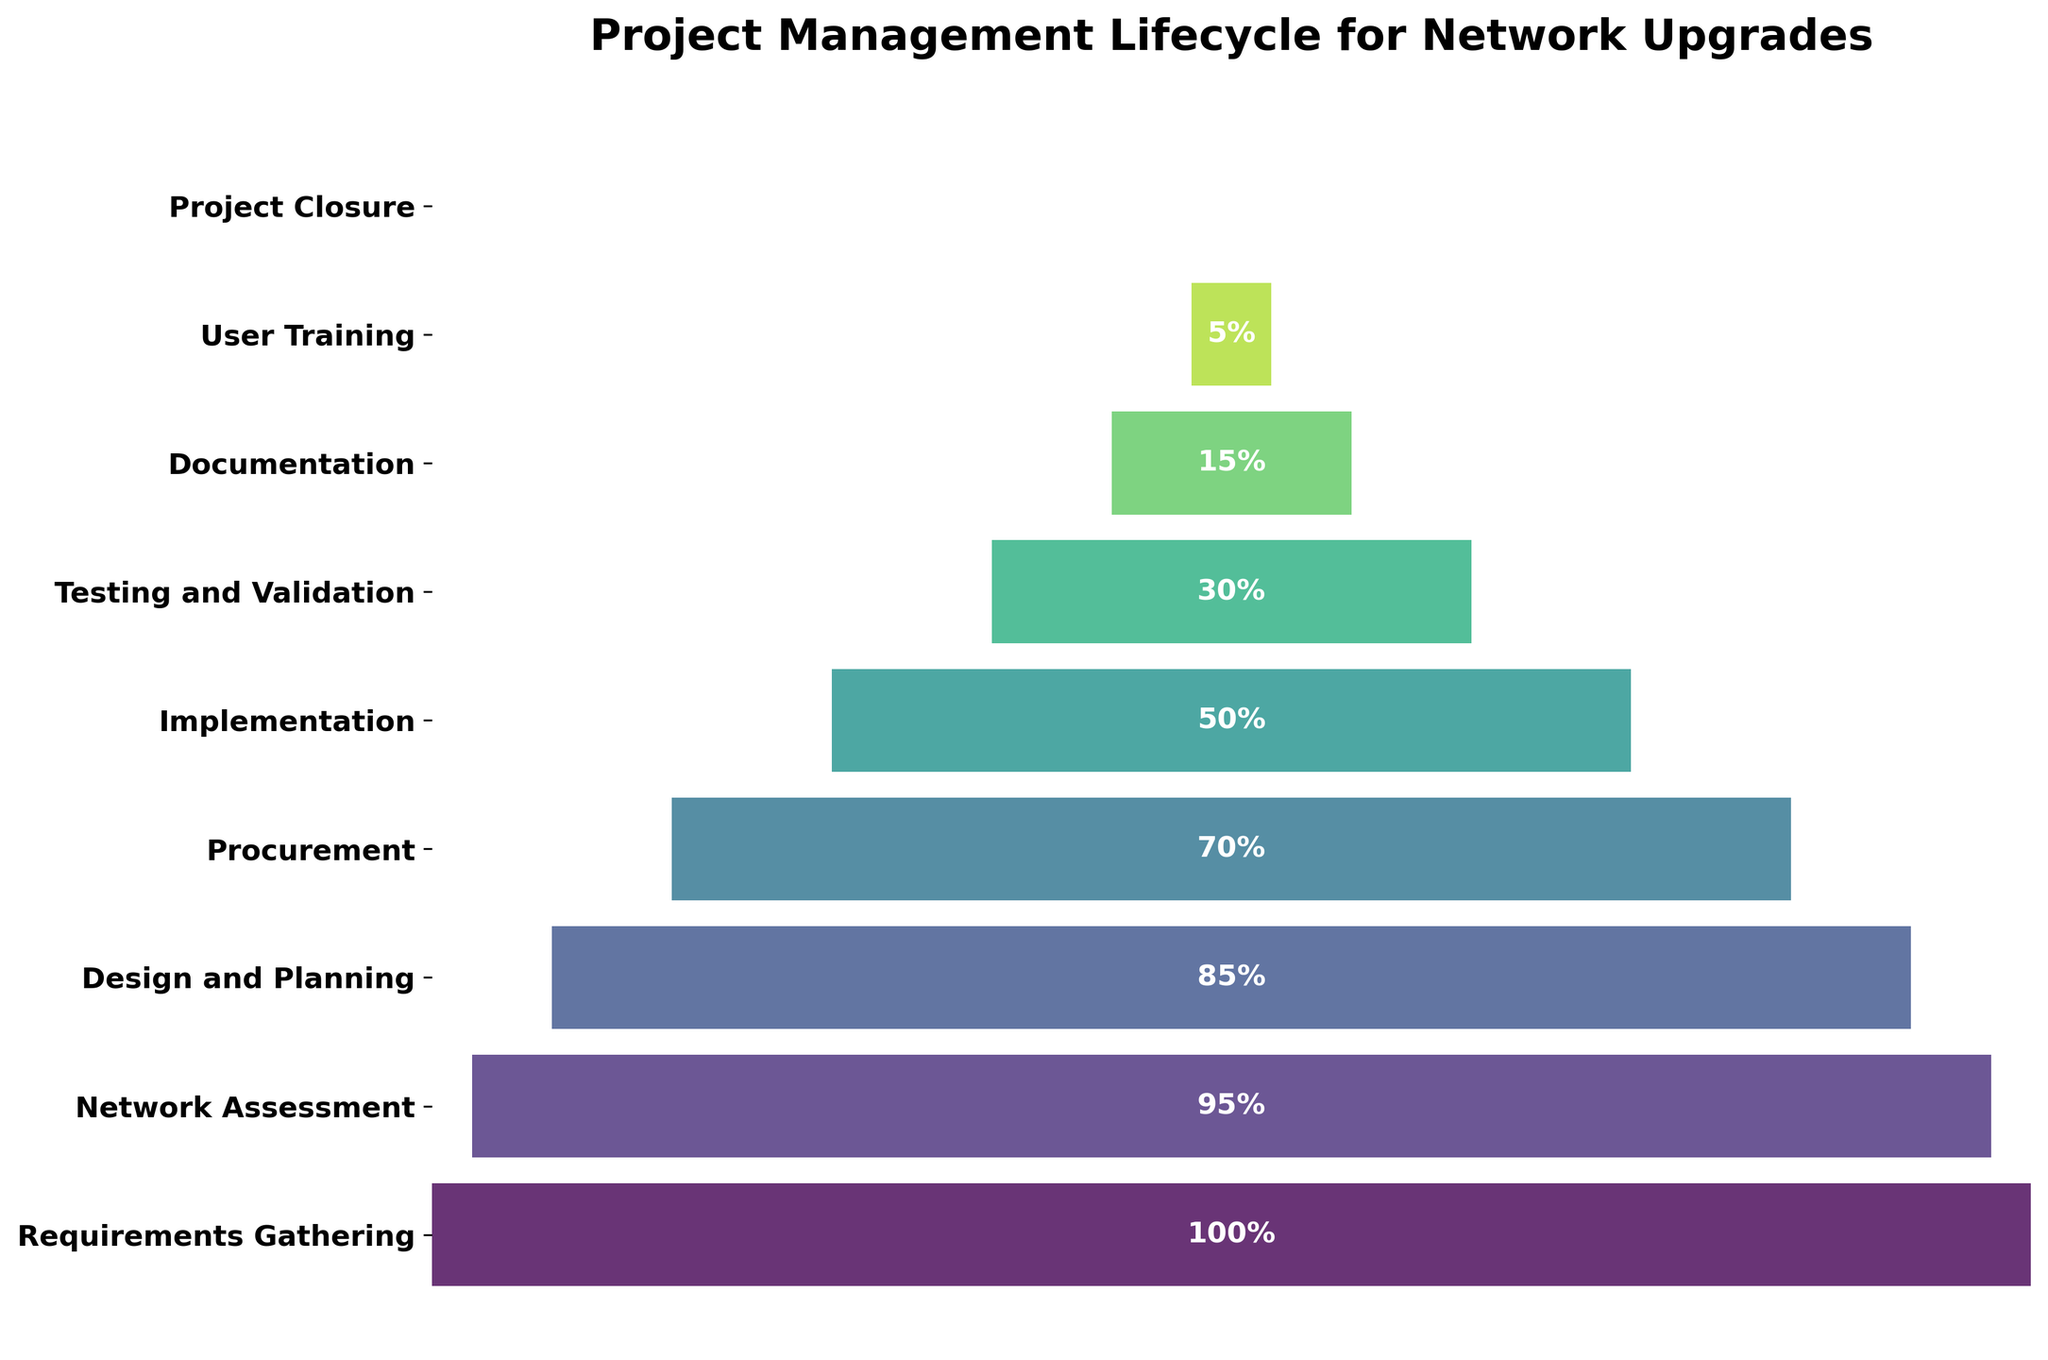Which phase has the highest completion percentage? The phase with the highest completion percentage is the one shown at the top of the funnel chart. By inspecting the chart, we can see that the topmost phase, "Requirements Gathering," has a completion percentage of 100%.
Answer: Requirements Gathering What is the difference in completion percentage between the "Procurement" and "Testing and Validation" phases? The completion percentage for "Procurement" is 70%, and for "Testing and Validation" it is 30%. The difference can be calculated by subtracting 30% from 70%.
Answer: 40% How many phases are listed in the funnel chart? The number of phases can be determined by counting the different horizontal bars in the funnel chart. The chart shows nine distinct phases.
Answer: 9 Which phase marks the halfway point in terms of completion percentage? The halfway point in terms of completion percentage is closest to 50%. The chart indicates that "Implementation" is the phase with a 50% completion percentage.
Answer: Implementation In which phase does the completion percentage drop below 20% for the first time? To determine the first phase where the completion percentage drops below 20%, we examine the percentages starting from the top. The "Documentation" phase is the first to drop below 20%, with a completion percentage of 15%.
Answer: Documentation What is the average completion percentage of all phases? To find the average, we sum all the completion percentages and divide by the number of phases. The sum is 100 + 95 + 85 + 70 + 50 + 30 + 15 + 5 + 0 = 450. Dividing by 9 phases gives us 450 / 9.
Answer: 50% Are there any phases with equal completion percentages? By examining the labels on the chart, we see that each phase has a unique completion percentage with no duplicates.
Answer: No What percentage of the project is completed by the end of the "Design and Planning" phase? To find out the cumulative percentage up to the "Design and Planning" phase, we look at its completion percentage. The "Design and Planning" phase has an 85% completion percentage.
Answer: 85% Between which two consecutive phases is the largest drop in completion percentage observed? To determine the largest drop, subtract the completion percentages of each consecutive pair of phases and compare the differences. The largest drop is between "Implementation" (50%) and "Testing and Validation" (30%), a difference of 20%.
Answer: Implementation and Testing and Validation What is the completion percentage for the final phase? The final phase at the bottom of the funnel is "Project Closure," and its completion percentage is indicated as 0%.
Answer: 0% 